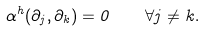<formula> <loc_0><loc_0><loc_500><loc_500>\alpha ^ { h } ( \partial _ { j } , \partial _ { k } ) = 0 \quad \forall j \neq k .</formula> 